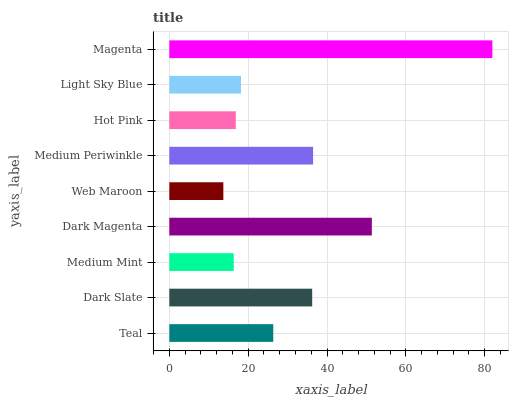Is Web Maroon the minimum?
Answer yes or no. Yes. Is Magenta the maximum?
Answer yes or no. Yes. Is Dark Slate the minimum?
Answer yes or no. No. Is Dark Slate the maximum?
Answer yes or no. No. Is Dark Slate greater than Teal?
Answer yes or no. Yes. Is Teal less than Dark Slate?
Answer yes or no. Yes. Is Teal greater than Dark Slate?
Answer yes or no. No. Is Dark Slate less than Teal?
Answer yes or no. No. Is Teal the high median?
Answer yes or no. Yes. Is Teal the low median?
Answer yes or no. Yes. Is Web Maroon the high median?
Answer yes or no. No. Is Light Sky Blue the low median?
Answer yes or no. No. 